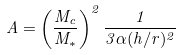<formula> <loc_0><loc_0><loc_500><loc_500>A = \left ( \frac { M _ { c } } { M _ { * } } \right ) ^ { 2 } \frac { 1 } { 3 \alpha ( h / r ) ^ { 2 } }</formula> 